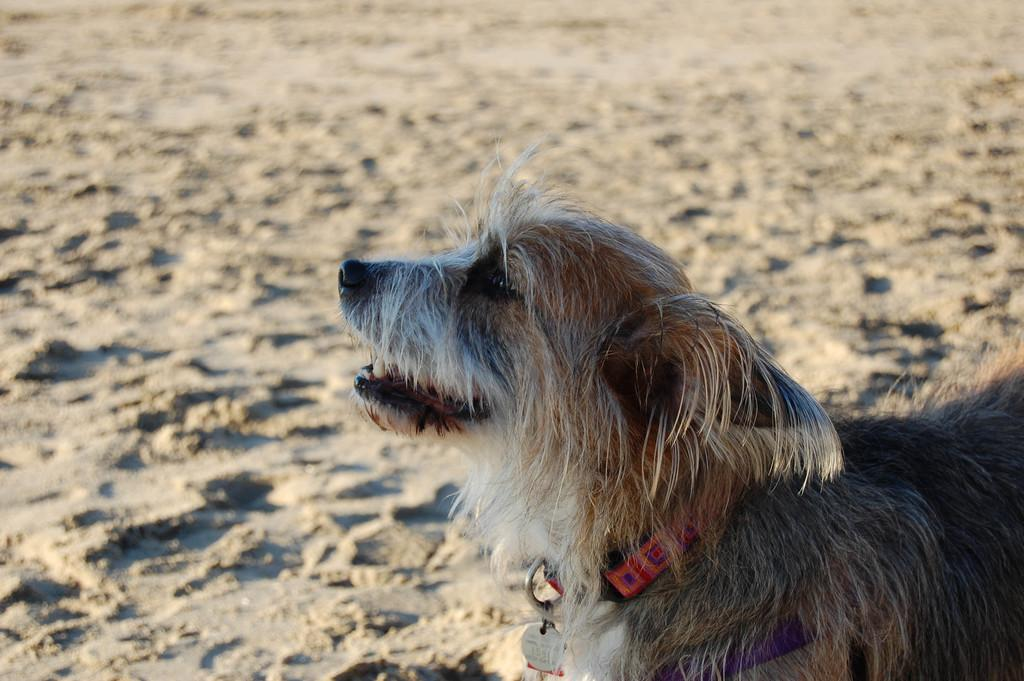What type of animal is in the image? There is a dog in the image. What color is the dog? The dog is brown in color. What is the background of the image made of? There is sand at the bottom of the image. What accessory is the dog wearing? The dog is wearing a red belt, specifically a red belt. What is attached to the dog's belt? There is a batch attached to the dog's belt. What type of cow can be seen playing baseball in the image? There is no cow or baseball present in the image; it features a dog wearing a red belt with a batch attached. 